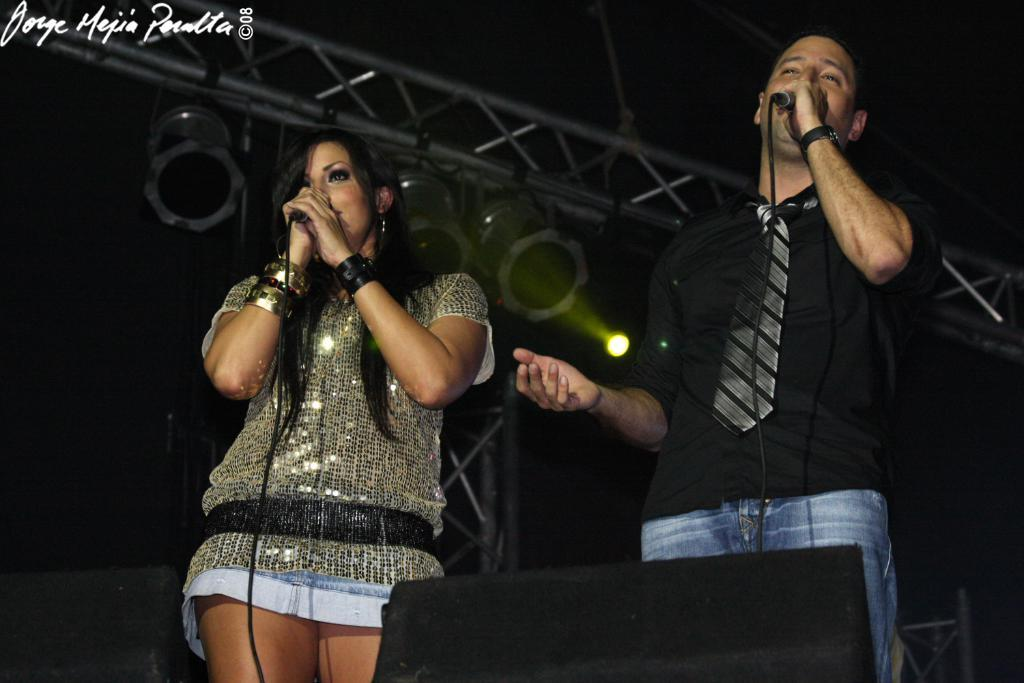Who are the people in the image? There is a woman and a man in the image. What are the woman and the man doing in the image? Both the woman and the man are singing on a microphone. Can you describe the lighting in the image? There is a light visible in the image. What type of nut is being cracked by the sky in the image? There is no nut or sky present in the image; it features a woman and a man singing on a microphone with a visible light. 